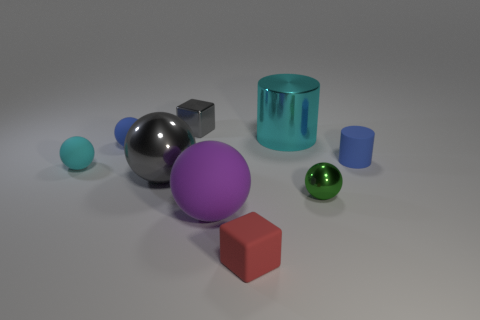Subtract 2 spheres. How many spheres are left? 3 Subtract all yellow balls. Subtract all purple cylinders. How many balls are left? 5 Subtract all cubes. How many objects are left? 7 Add 1 blue spheres. How many blue spheres exist? 2 Subtract 0 yellow blocks. How many objects are left? 9 Subtract all big green metal blocks. Subtract all large things. How many objects are left? 6 Add 6 big gray spheres. How many big gray spheres are left? 7 